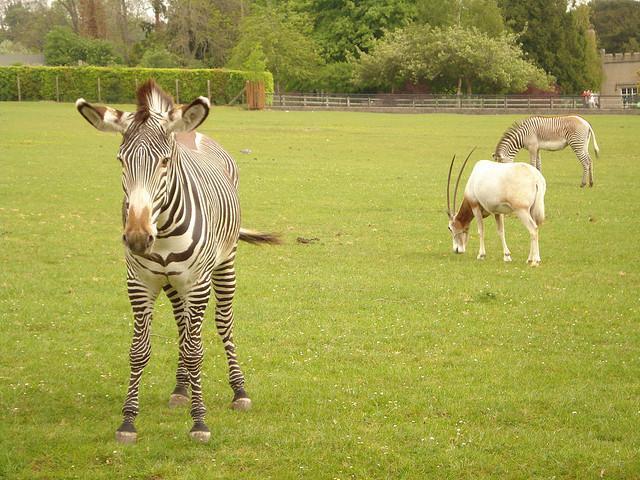How many zebras are in this picture?
Give a very brief answer. 2. How many zebras are in the photo?
Give a very brief answer. 2. 